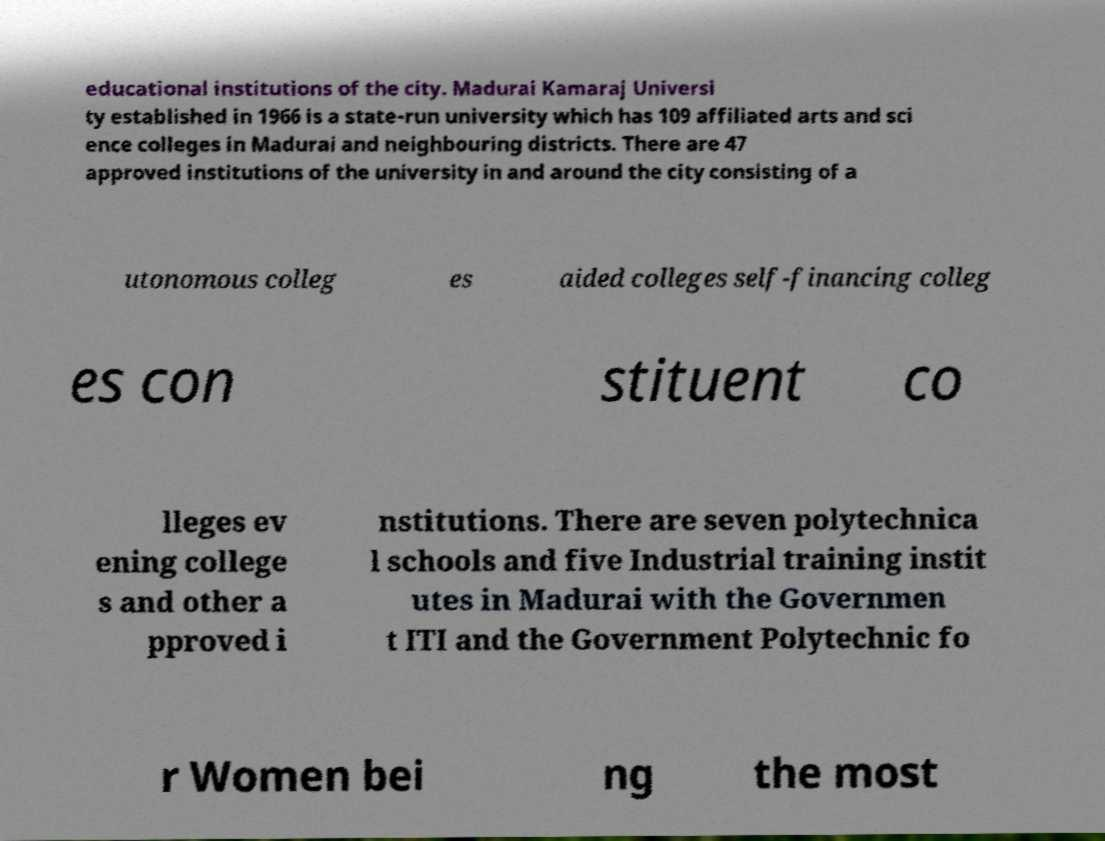What messages or text are displayed in this image? I need them in a readable, typed format. educational institutions of the city. Madurai Kamaraj Universi ty established in 1966 is a state-run university which has 109 affiliated arts and sci ence colleges in Madurai and neighbouring districts. There are 47 approved institutions of the university in and around the city consisting of a utonomous colleg es aided colleges self-financing colleg es con stituent co lleges ev ening college s and other a pproved i nstitutions. There are seven polytechnica l schools and five Industrial training instit utes in Madurai with the Governmen t ITI and the Government Polytechnic fo r Women bei ng the most 